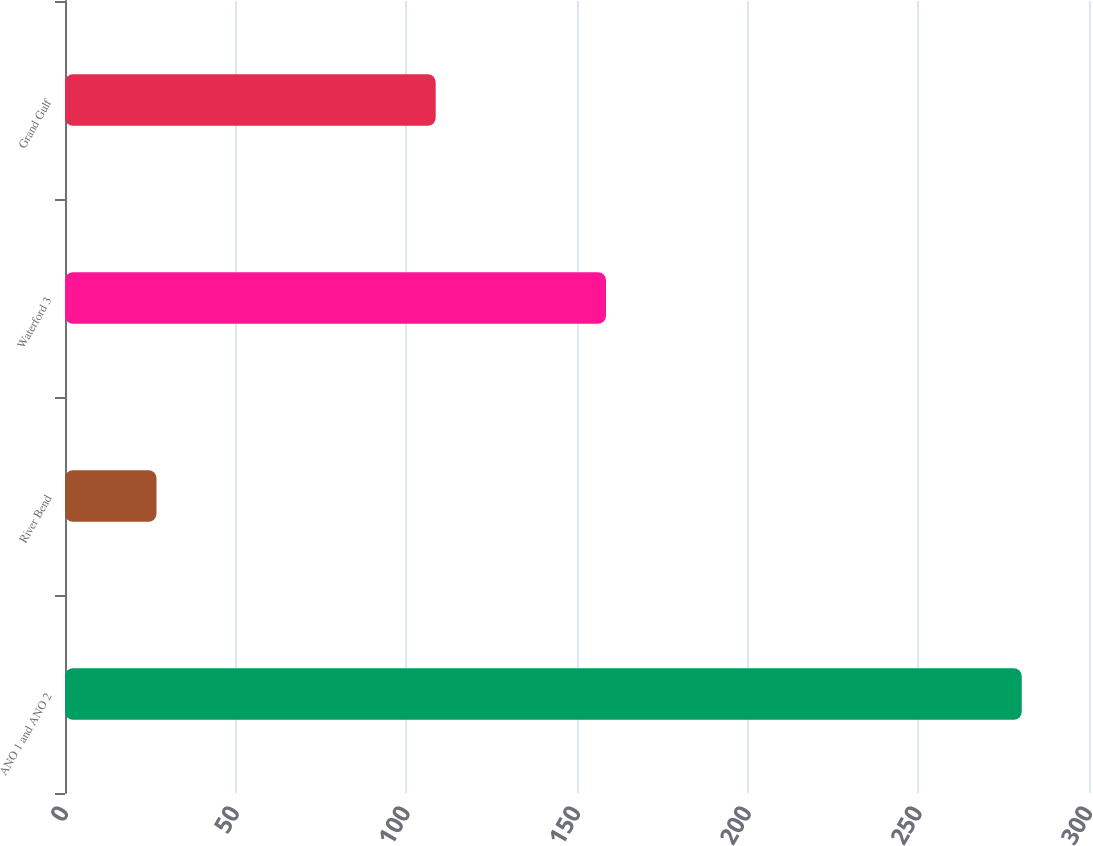Convert chart to OTSL. <chart><loc_0><loc_0><loc_500><loc_500><bar_chart><fcel>ANO 1 and ANO 2<fcel>River Bend<fcel>Waterford 3<fcel>Grand Gulf<nl><fcel>280.3<fcel>26.8<fcel>158.5<fcel>108.6<nl></chart> 